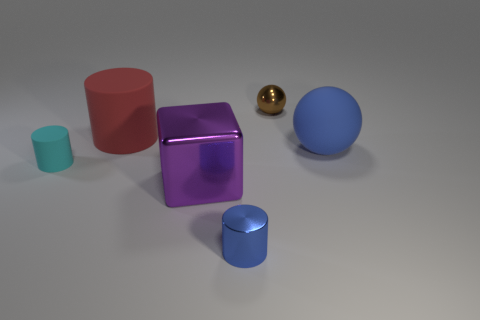Add 3 tiny blue metallic things. How many objects exist? 9 Subtract all cubes. How many objects are left? 5 Subtract 0 gray cubes. How many objects are left? 6 Subtract all big green balls. Subtract all small metal balls. How many objects are left? 5 Add 3 large rubber cylinders. How many large rubber cylinders are left? 4 Add 6 large blue things. How many large blue things exist? 7 